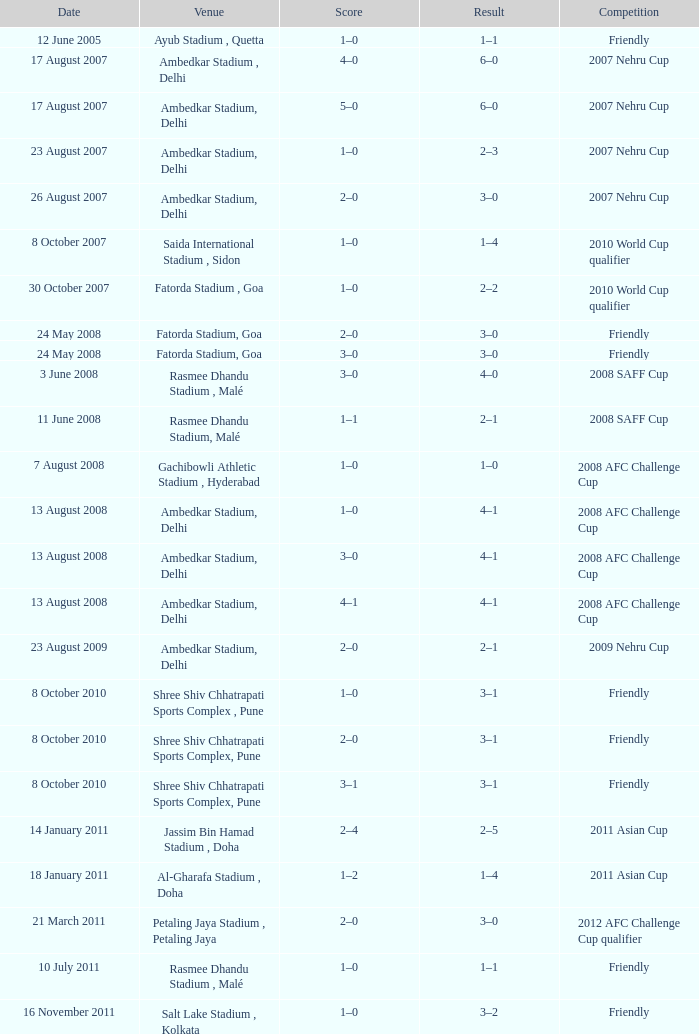What was the score on august 22, 2012? 1–0. 